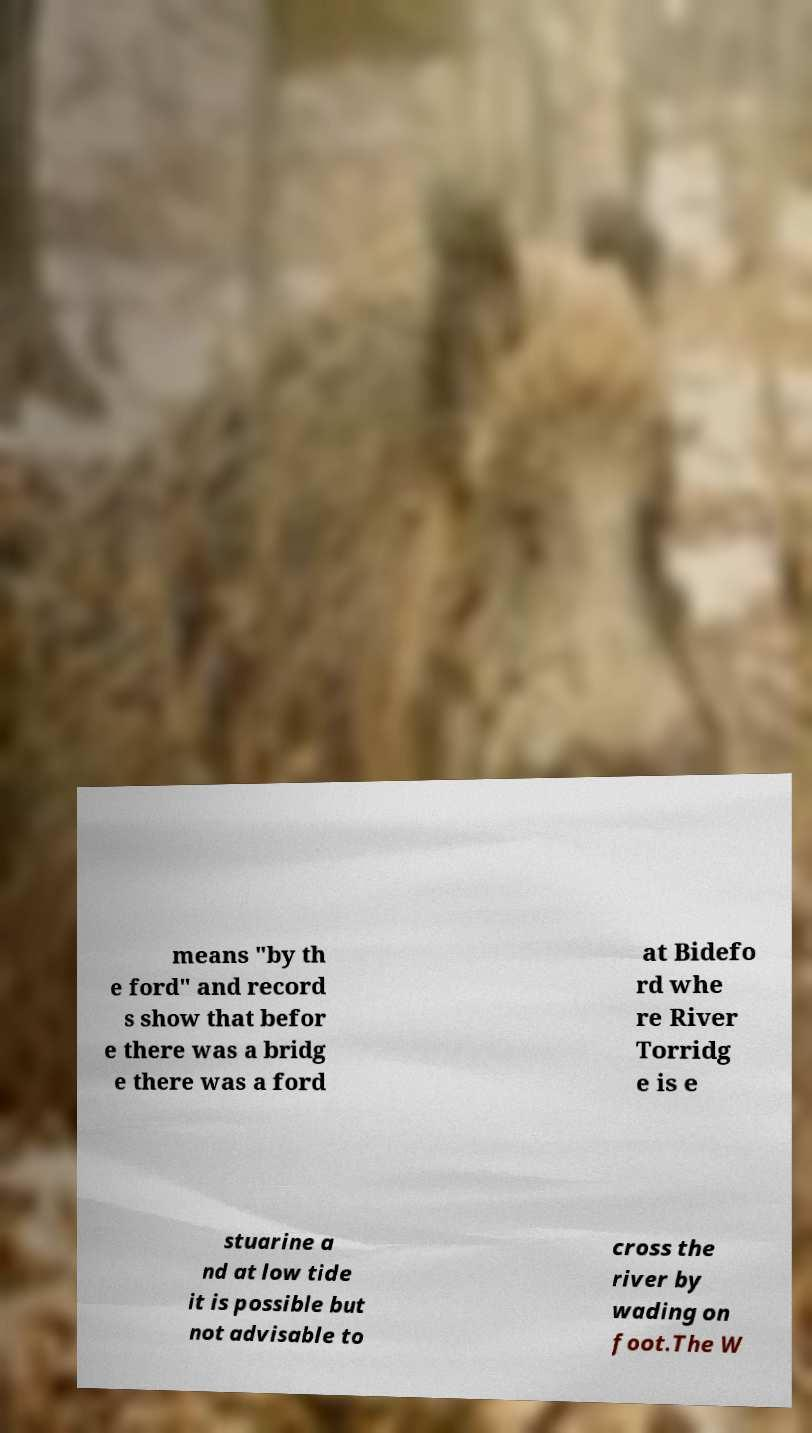For documentation purposes, I need the text within this image transcribed. Could you provide that? means "by th e ford" and record s show that befor e there was a bridg e there was a ford at Bidefo rd whe re River Torridg e is e stuarine a nd at low tide it is possible but not advisable to cross the river by wading on foot.The W 